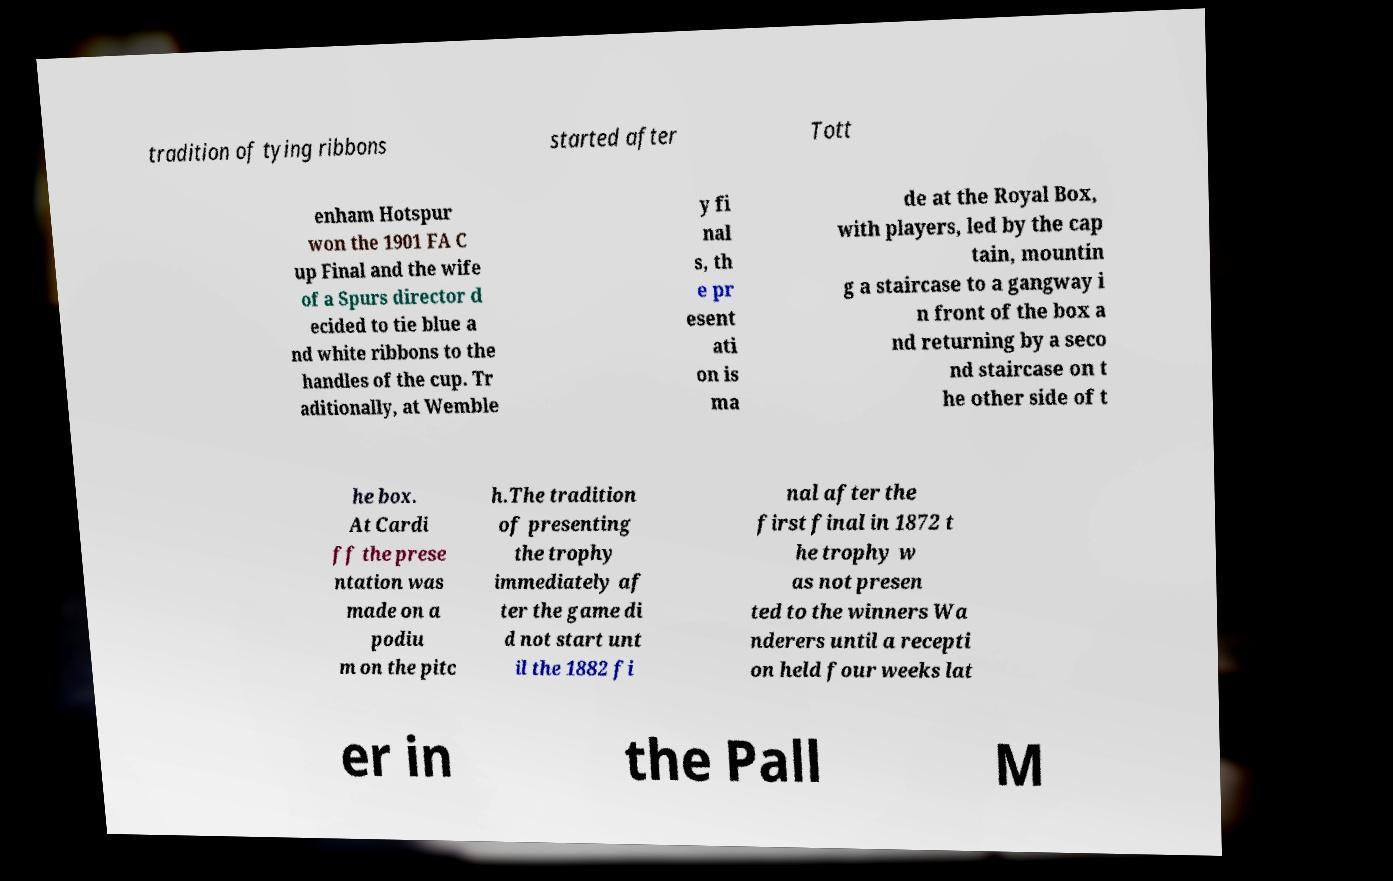Could you extract and type out the text from this image? tradition of tying ribbons started after Tott enham Hotspur won the 1901 FA C up Final and the wife of a Spurs director d ecided to tie blue a nd white ribbons to the handles of the cup. Tr aditionally, at Wemble y fi nal s, th e pr esent ati on is ma de at the Royal Box, with players, led by the cap tain, mountin g a staircase to a gangway i n front of the box a nd returning by a seco nd staircase on t he other side of t he box. At Cardi ff the prese ntation was made on a podiu m on the pitc h.The tradition of presenting the trophy immediately af ter the game di d not start unt il the 1882 fi nal after the first final in 1872 t he trophy w as not presen ted to the winners Wa nderers until a recepti on held four weeks lat er in the Pall M 